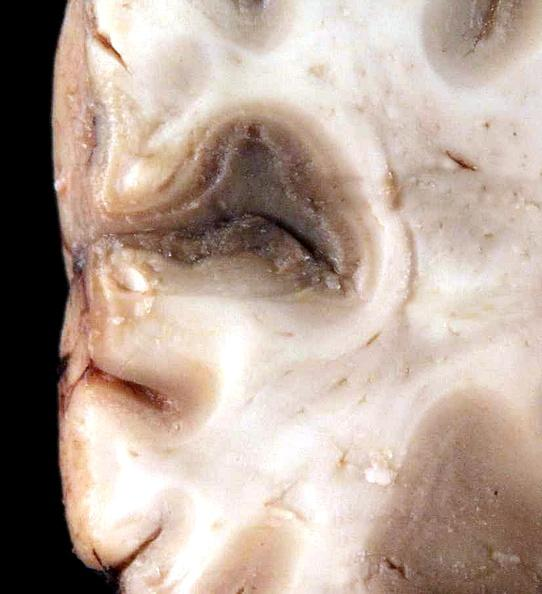what does this image show?
Answer the question using a single word or phrase. Brain 